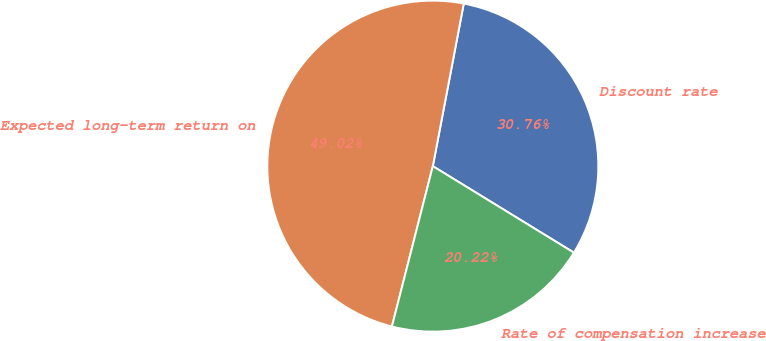Convert chart. <chart><loc_0><loc_0><loc_500><loc_500><pie_chart><fcel>Discount rate<fcel>Expected long-term return on<fcel>Rate of compensation increase<nl><fcel>30.76%<fcel>49.02%<fcel>20.22%<nl></chart> 